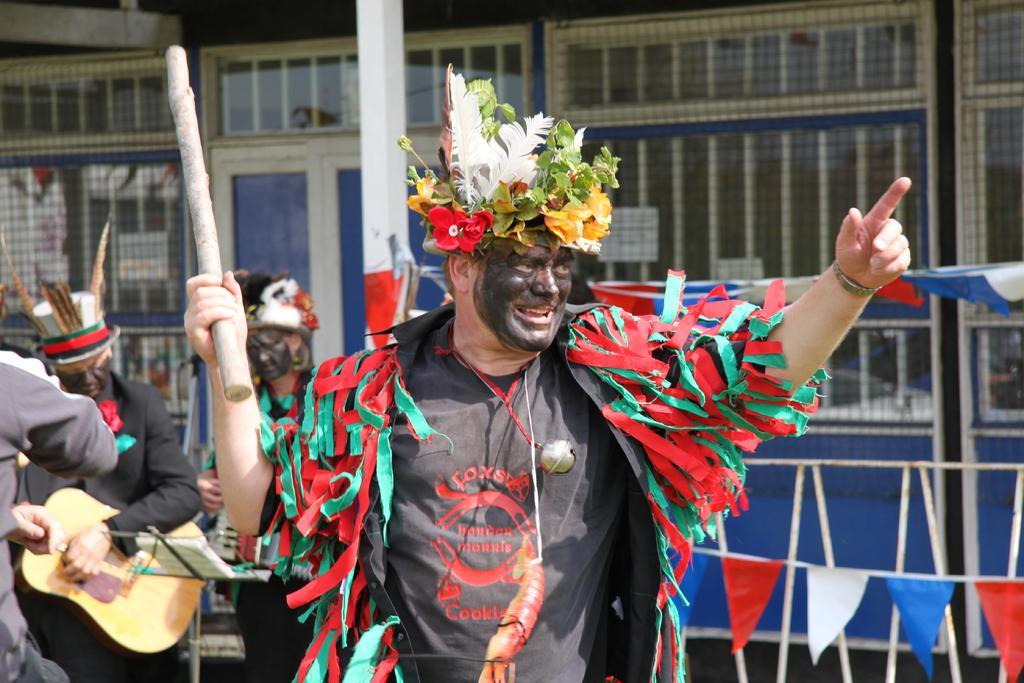Can you describe this image briefly? There is a man with black t-shirt. He is standing. On him there are colorful ribbons. To his face there is a black color mask. On his head there is crown with leaves. He is holding a stick in his hands. And behind him there are some peoples standing and playing guitar. There is a door at the back side. And to the left there is a window. 